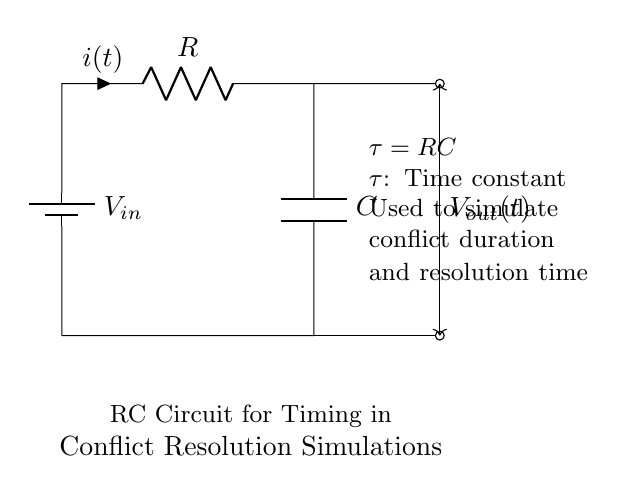What is the input voltage of the circuit? The input voltage, labeled as V_sub_in, is the potential difference provided by the battery in the circuit. This is indicated at the top left side of the diagram.
Answer: V_in What component is responsible for storing charge? The capacitor, labeled as C, is the component in the circuit that stores electrical energy in an electric field, allowing for the timing function needed in simulations.
Answer: C What is the time constant in this RC circuit? The time constant, which determines how quickly the circuit responds to changes in voltage, is represented by the formula τ = RC. This is specified in the text within the diagram.
Answer: τ = RC What does the current flow direction indicate? The current flow direction is shown by the arrow on the resistor, indicating how the charge moves through the circuit during operation.
Answer: Current direction What impacts the conflict duration in the simulation? The time constant τ = RC controls the timing characteristics of the circuit, directly impacting how long the simulation runs to model conflict duration and resolution time.
Answer: τ = RC What type of circuit is shown in the diagram? The circuit shown is classified as an RC circuit, characterized by the presence of a resistor and a capacitor connected together with a voltage source. This is typical for timing applications.
Answer: RC circuit 